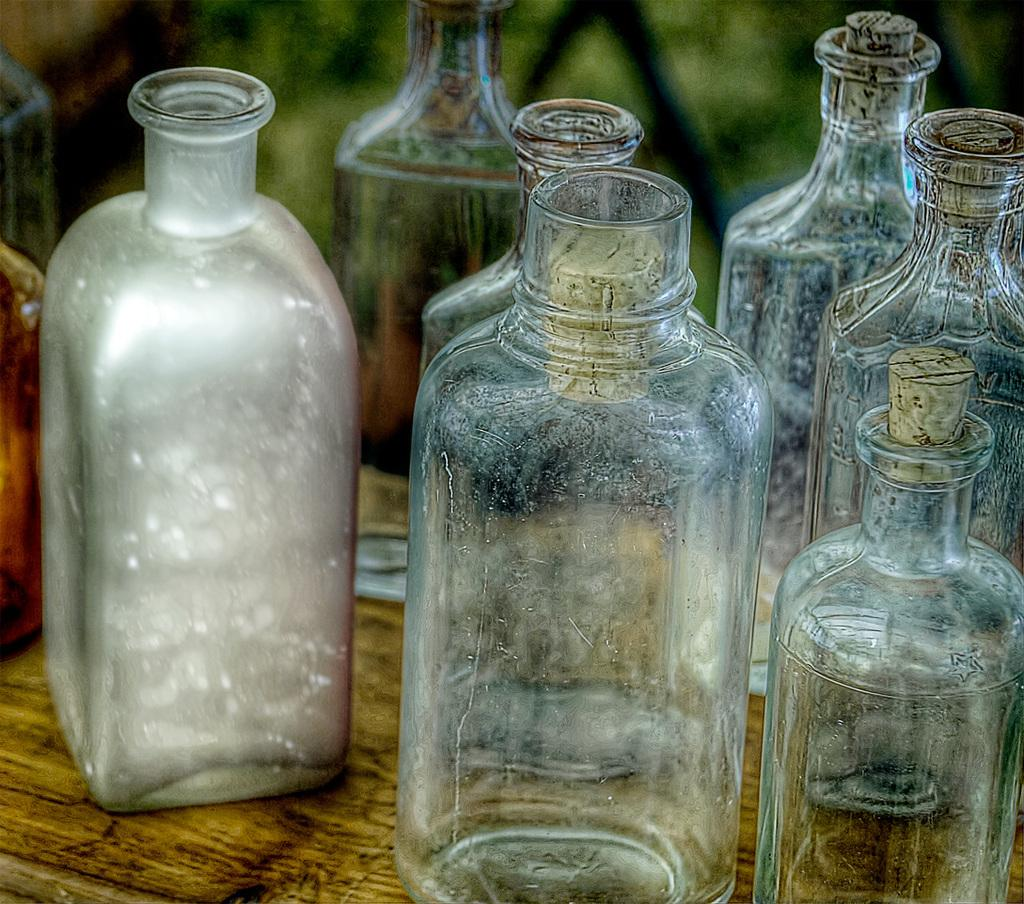What objects are visible in the image? There are bottles in the image. Where are the bottles located? The bottles are placed on a table. Is there a receipt visible on the table next to the bottles? There is no mention of a receipt in the provided facts, so we cannot determine if one is present in the image. 